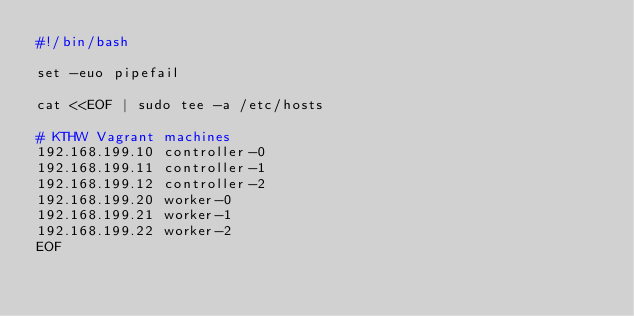Convert code to text. <code><loc_0><loc_0><loc_500><loc_500><_Bash_>#!/bin/bash

set -euo pipefail

cat <<EOF | sudo tee -a /etc/hosts

# KTHW Vagrant machines
192.168.199.10 controller-0
192.168.199.11 controller-1
192.168.199.12 controller-2
192.168.199.20 worker-0
192.168.199.21 worker-1
192.168.199.22 worker-2
EOF
</code> 